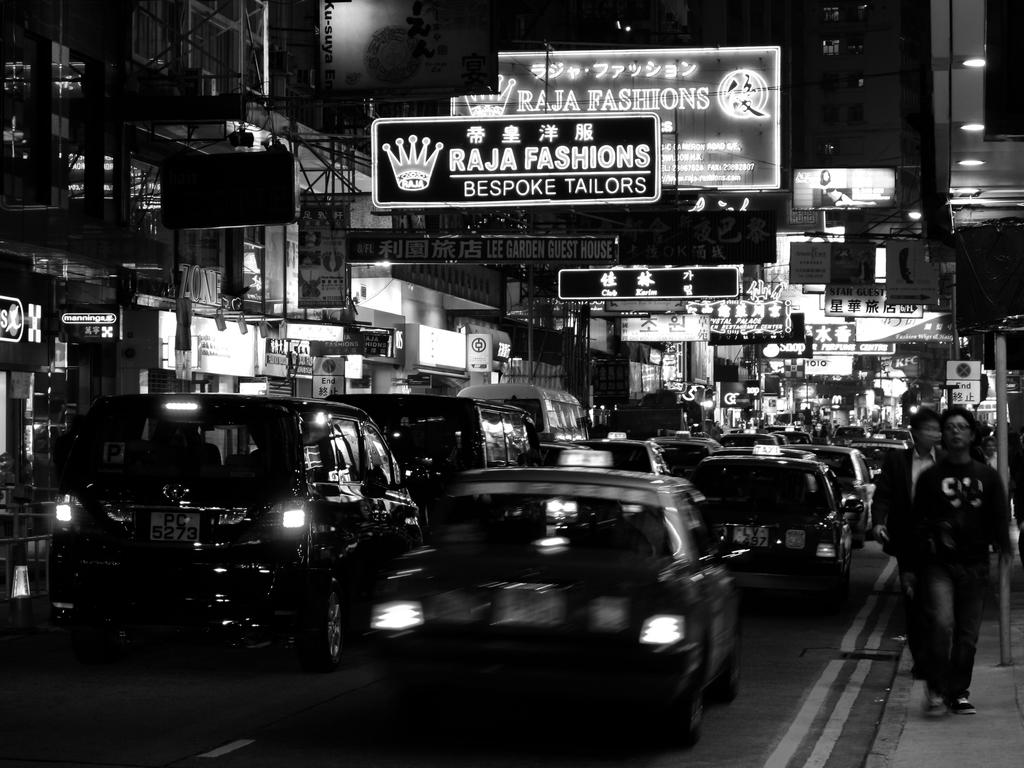<image>
Relay a brief, clear account of the picture shown. A billboard advertising Raja Fashions has a crown on it. 